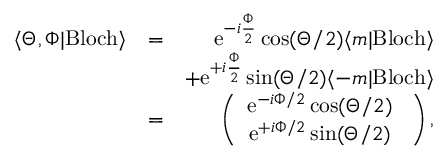<formula> <loc_0><loc_0><loc_500><loc_500>\begin{array} { r l r } { \langle \Theta , \Phi | B l o c h \rangle } & { = } & { e ^ { - i \frac { \Phi } { 2 } } \cos ( \Theta / 2 ) \langle m | B l o c h \rangle } \\ & { + e ^ { + i \frac { \Phi } { 2 } } \sin ( \Theta / 2 ) \langle - m | B l o c h \rangle } \\ & { = } & { \left ( \begin{array} { c } { e ^ { - i \Phi / 2 } \cos ( \Theta / 2 ) \ } \\ { e ^ { + i \Phi / 2 } \sin ( \Theta / 2 ) \ } \end{array} \right ) , } \end{array}</formula> 